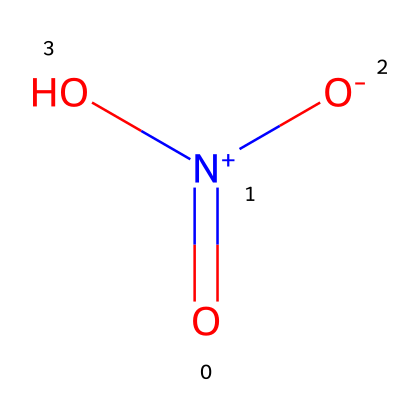What is the name of this chemical? The structure represents a nitro group, specifically nitrous acid (HNO2) when considering the given SMILES. The key is in identifying the nitrogen atom bonded to three oxygens, one of which is double-bonded.
Answer: nitrous acid How many oxygen atoms are present in this molecule? The SMILES representation shows three oxygen atoms connected to the nitrogen atom; one of them is in a double bond, and the other two have single bonds, confirming three oxygen atoms total.
Answer: three What type of chemical bond is present between the nitrogen and the double-bonded oxygen? The structure indicates a double bond between the nitrogen and the oxygen, shown by the "=" symbol in the SMILES representation, which is characteristic for certain groups such as nitro compounds.
Answer: double bond What functional group is represented in this chemical structure? The presence of a nitrogen atom bonded to oxygen atoms, particularly in this arrangement, is indicative of a nitro functional group, commonly associated with various pollutants.
Answer: nitro group What is the oxidation state of nitrogen in this compound? To determine this, we assess the formal charge considering nitrogen is bonded to three oxygens: two single bonds and one double bond, which typically results in a +3 oxidation state.
Answer: +3 Is this molecule likely to participate in acid-base reactions? Given the nature of the nitro group and the presence of a proton (since it can dissociate), this molecule can indeed partake in acid-base chemistry, particularly in environmental contexts as a pollutant.
Answer: yes What atmospheric condition can lead to the formation of this chemical? The chemical is commonly produced through combustion processes in urban environments, especially under conditions where nitrogen oxides are emitted, subsequently leading to reactions that form nitrous acid.
Answer: combustion 